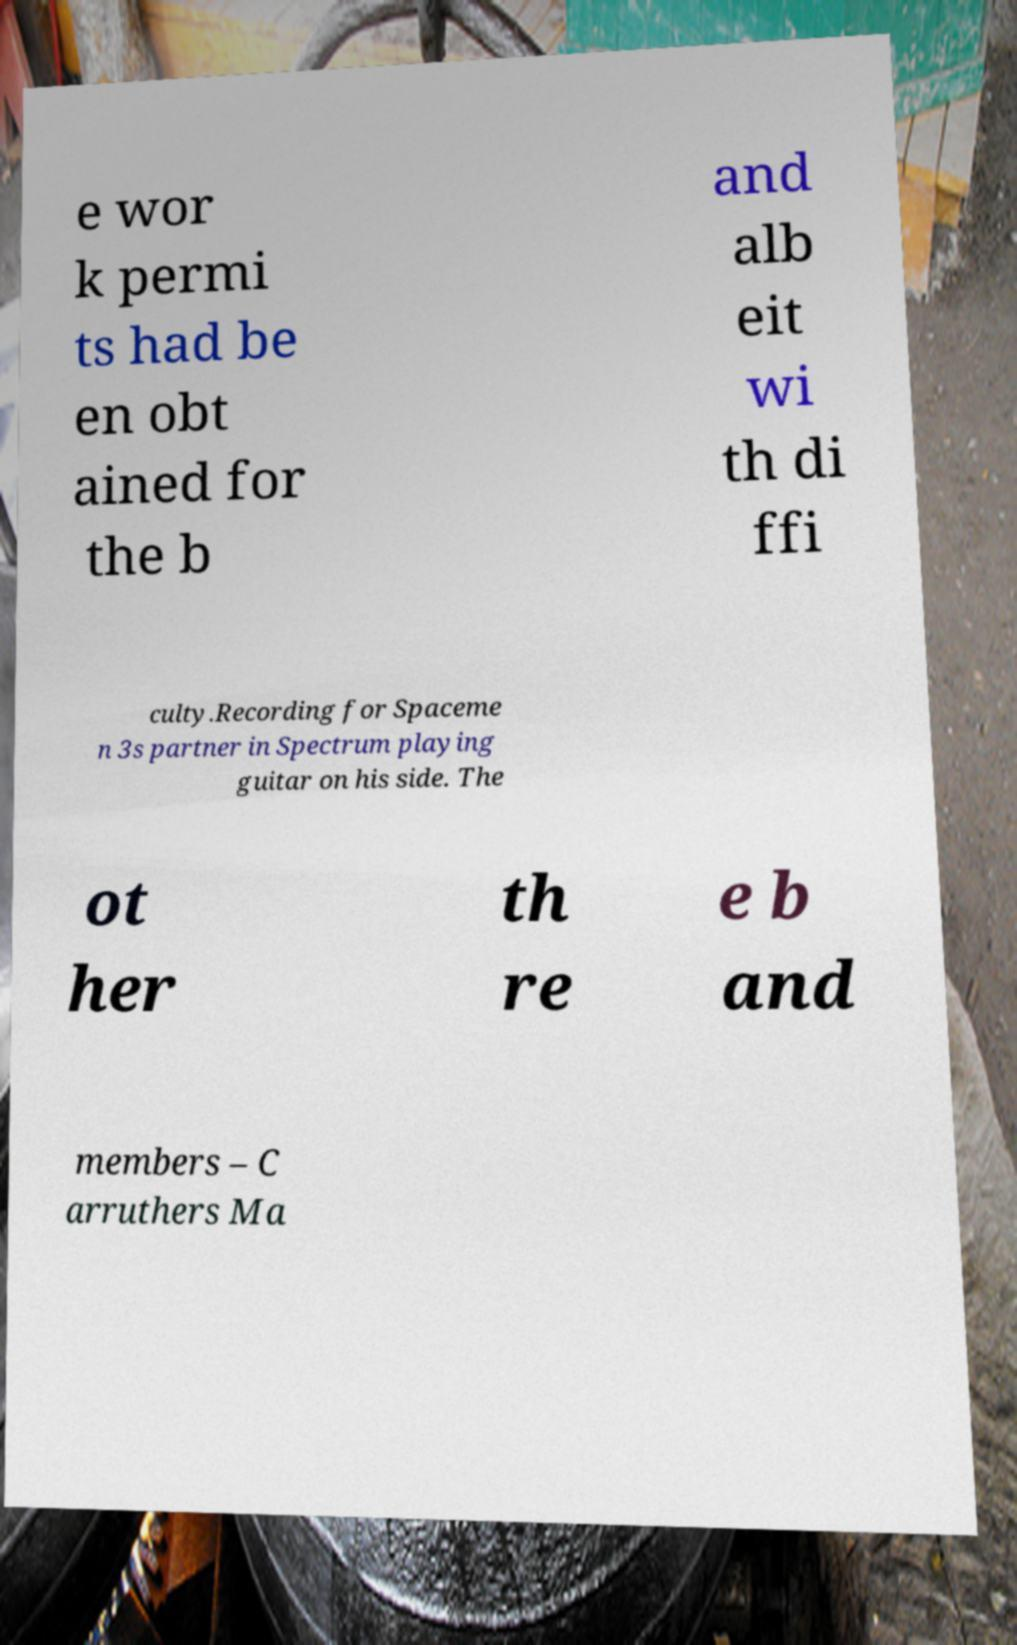Can you read and provide the text displayed in the image?This photo seems to have some interesting text. Can you extract and type it out for me? e wor k permi ts had be en obt ained for the b and alb eit wi th di ffi culty.Recording for Spaceme n 3s partner in Spectrum playing guitar on his side. The ot her th re e b and members – C arruthers Ma 